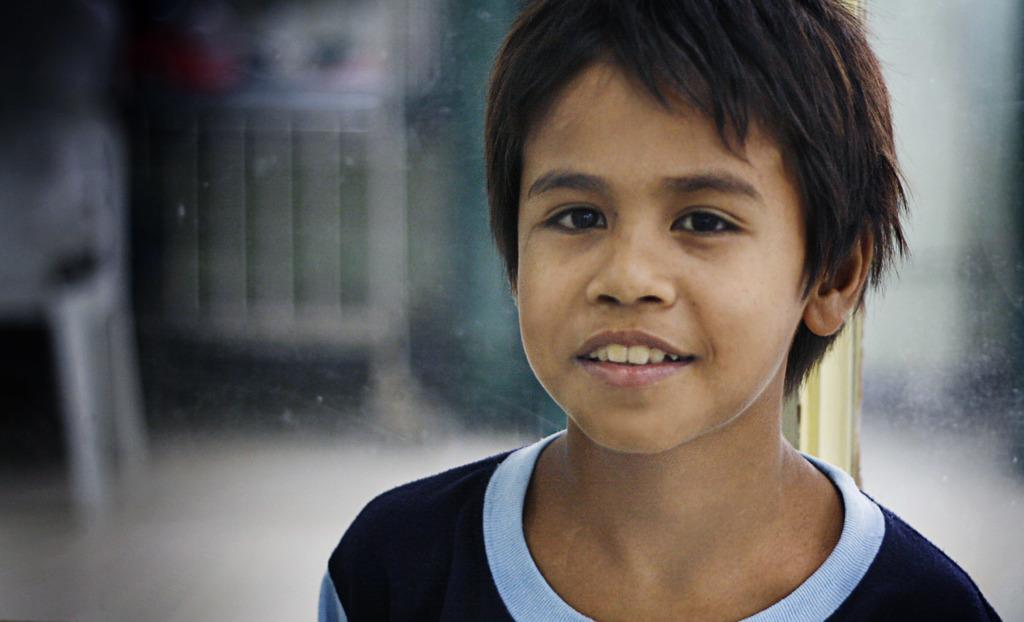Who is the main subject in the image? There is a boy in the image. What is the boy doing in the image? The boy is smiling in the image. What is the boy wearing in the image? The boy is wearing a blue t-shirt in the image. What type of credit card is the boy holding in the image? There is no credit card present in the image; the boy is simply smiling and wearing a blue t-shirt. 